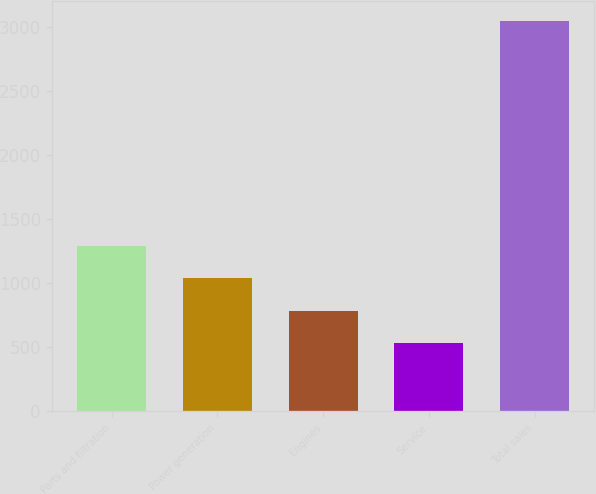<chart> <loc_0><loc_0><loc_500><loc_500><bar_chart><fcel>Parts and filtration<fcel>Power generation<fcel>Engines<fcel>Service<fcel>Total sales<nl><fcel>1287<fcel>1036<fcel>785<fcel>534<fcel>3044<nl></chart> 